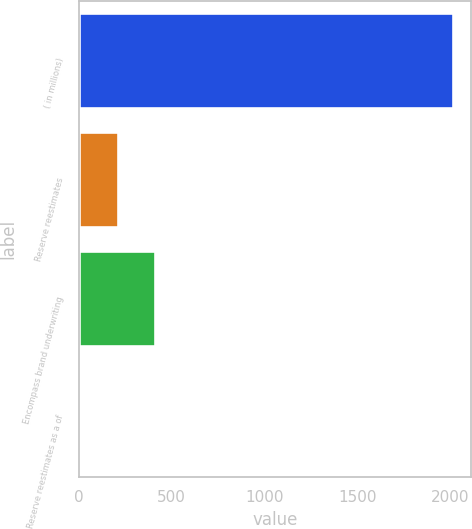Convert chart. <chart><loc_0><loc_0><loc_500><loc_500><bar_chart><fcel>( in millions)<fcel>Reserve reestimates<fcel>Encompass brand underwriting<fcel>Reserve reestimates as a of<nl><fcel>2011<fcel>210.37<fcel>410.44<fcel>10.3<nl></chart> 